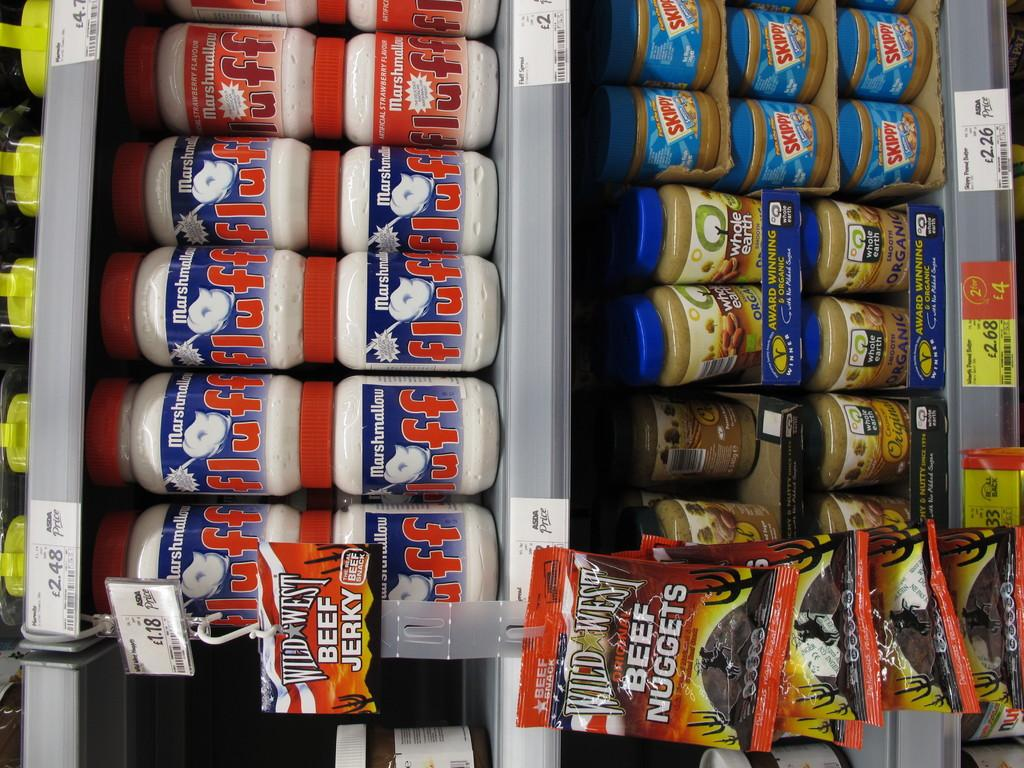Provide a one-sentence caption for the provided image. Beef Nuggets are hanging from the clips on the isle. 